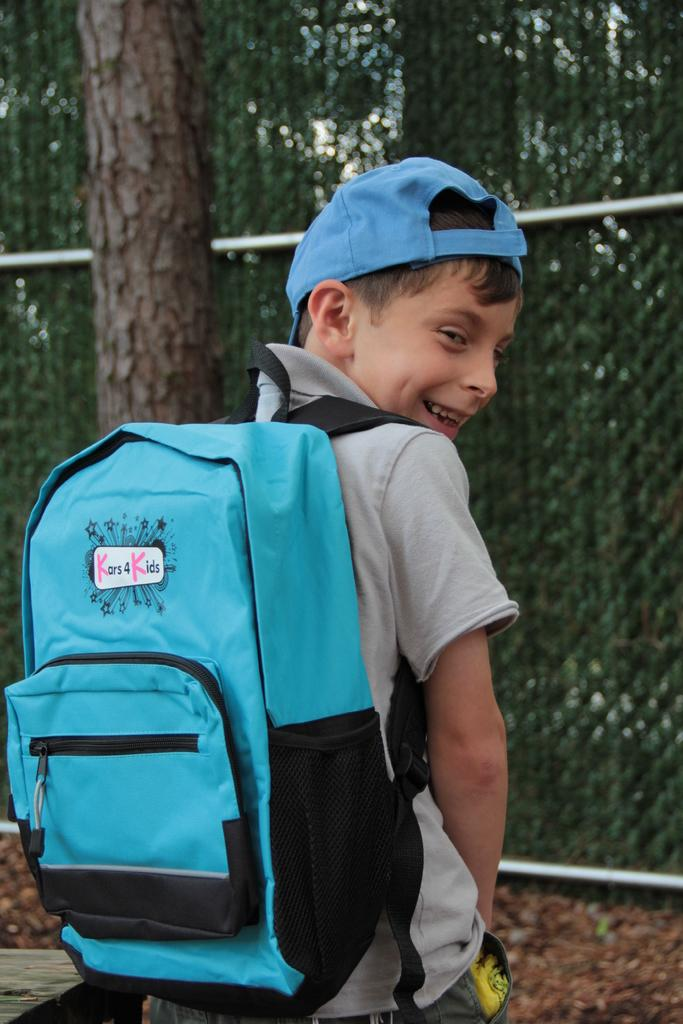<image>
Render a clear and concise summary of the photo. a boy wearing a blue backpack that says 'kars4kids' 